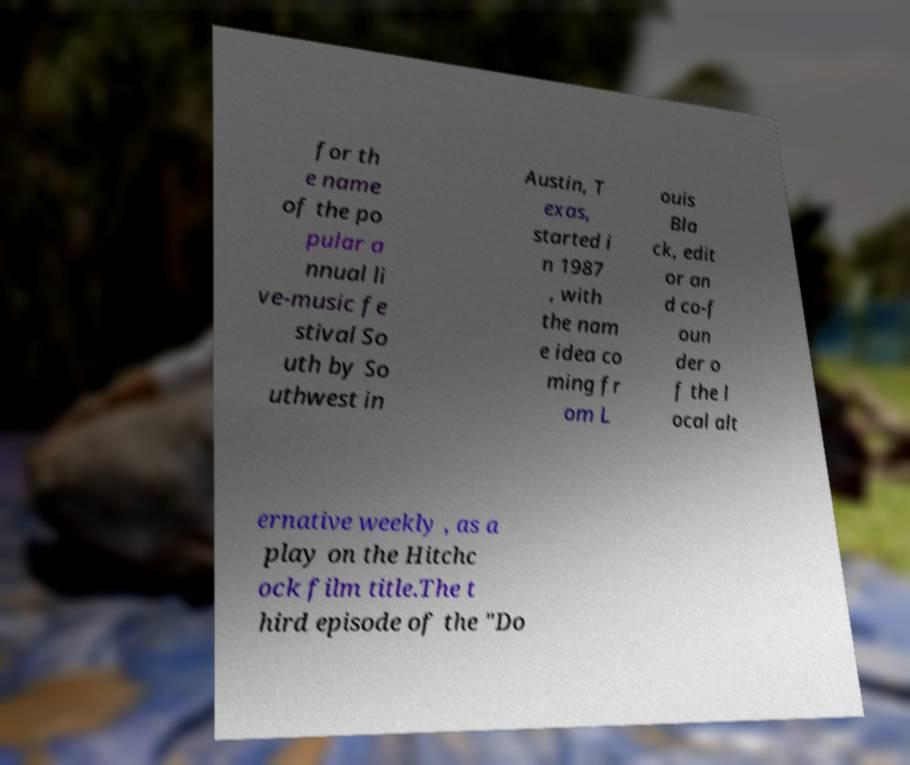Please identify and transcribe the text found in this image. for th e name of the po pular a nnual li ve-music fe stival So uth by So uthwest in Austin, T exas, started i n 1987 , with the nam e idea co ming fr om L ouis Bla ck, edit or an d co-f oun der o f the l ocal alt ernative weekly , as a play on the Hitchc ock film title.The t hird episode of the "Do 